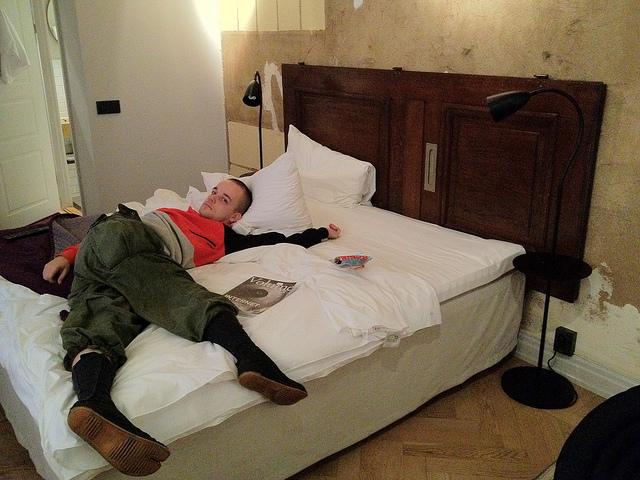Does this man look comfortable?
Answer briefly. No. What is on the bed with the person?
Be succinct. Magazine. Is the person wearing shoes?
Write a very short answer. Yes. Is there anything unique about the man's shoes?
Concise answer only. Yes. How many pillows are on the bed?
Short answer required. 2. 